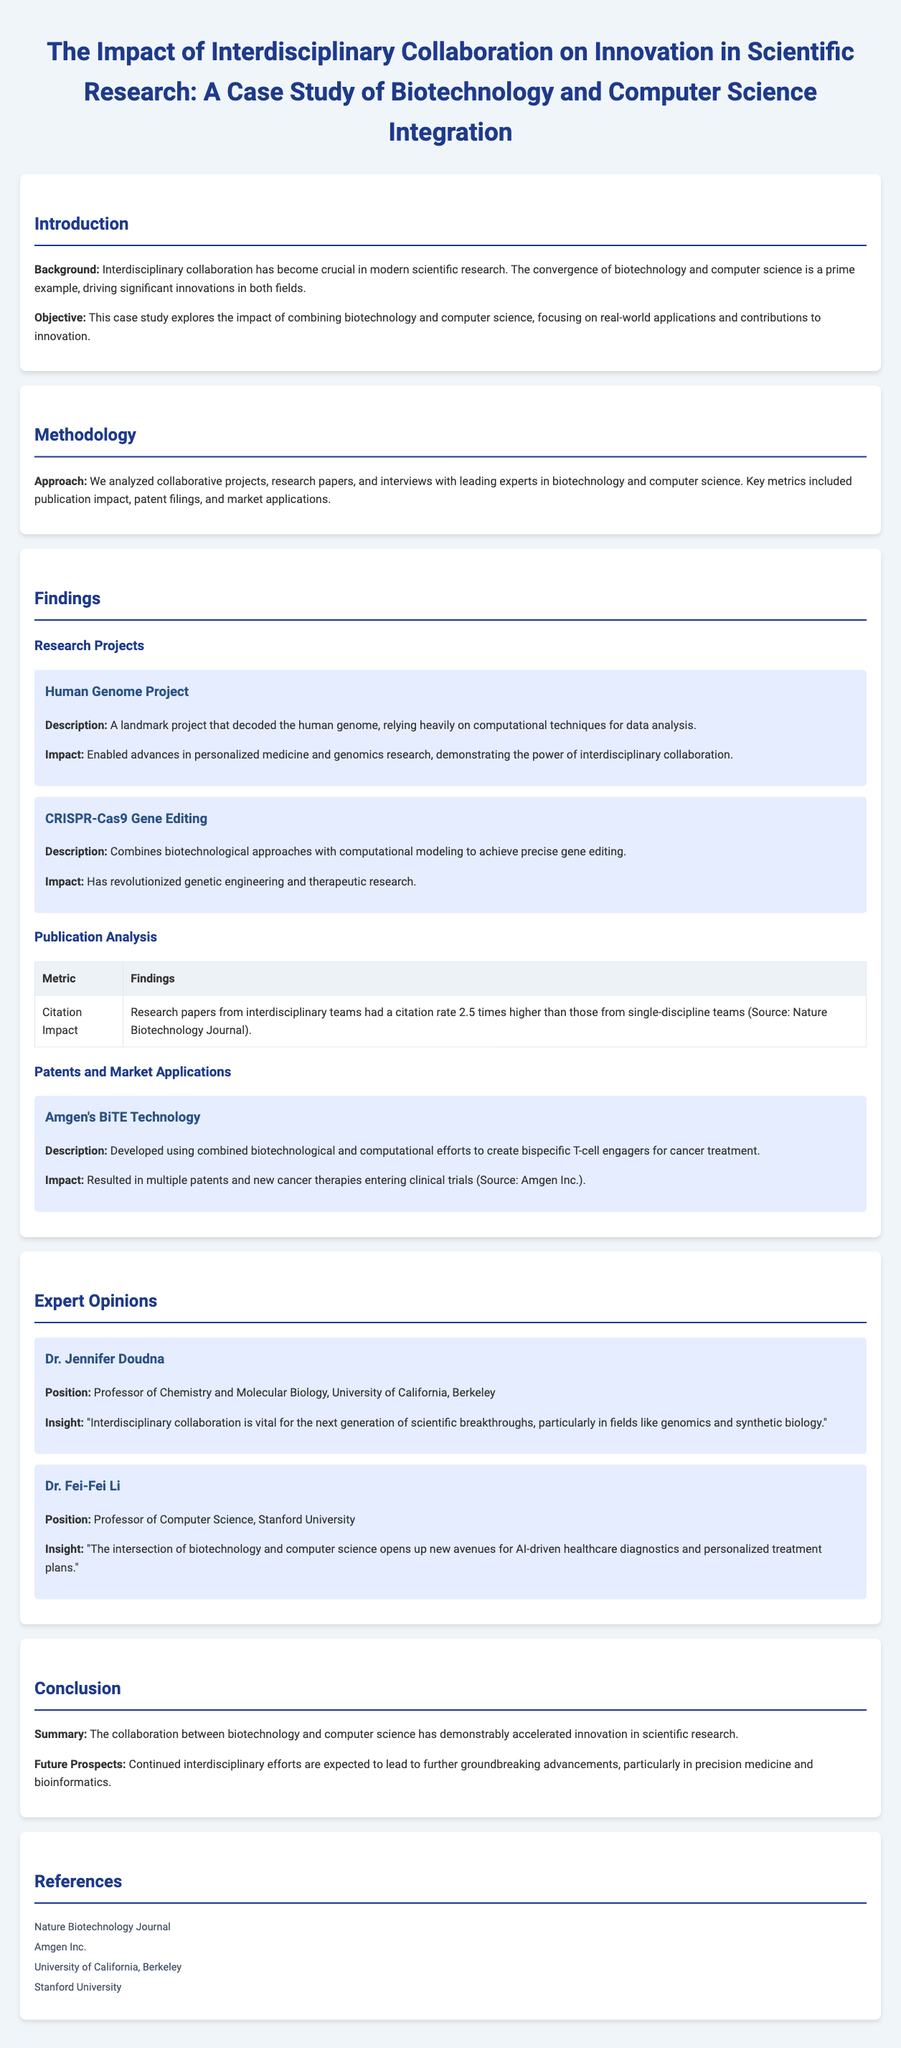What is the title of the case study? The title of the case study is explicitly stated at the beginning of the document.
Answer: The Impact of Interdisciplinary Collaboration on Innovation in Scientific Research: A Case Study of Biotechnology and Computer Science Integration What is the citation impact increase for interdisciplinary teams? The document provides a specific statistic regarding the citation impact of research papers from interdisciplinary teams compared to single-discipline teams.
Answer: 2.5 times Who is the professor of Chemistry and Molecular Biology mentioned? The case study includes expert opinions and specifically mentions the position and name of one expert.
Answer: Dr. Jennifer Doudna What is the main contribution of the Human Genome Project mentioned? The document highlights the specific impact of the Human Genome Project as an example of successful interdisciplinary collaboration.
Answer: Enabled advances in personalized medicine and genomics research What technology did Amgen develop using interdisciplinary efforts? The researched project by Amgen is explicitly named in the section discussing patents and market applications.
Answer: BiTE Technology What is the expected future prospect mentioned in the conclusion? The concluding section discusses the anticipated outcomes and prospects in the field of research due to continued collaboration.
Answer: Groundbreaking advancements What are the two fields integrated in the case study? The introduction of the case study specifies the two disciplines that are the focus of the interdisciplinary collaboration.
Answer: Biotechnology and computer science What is the role of Dr. Fei-Fei Li? The opinion section lists Dr. Fei-Fei Li's position within the context of the document.
Answer: Professor of Computer Science 